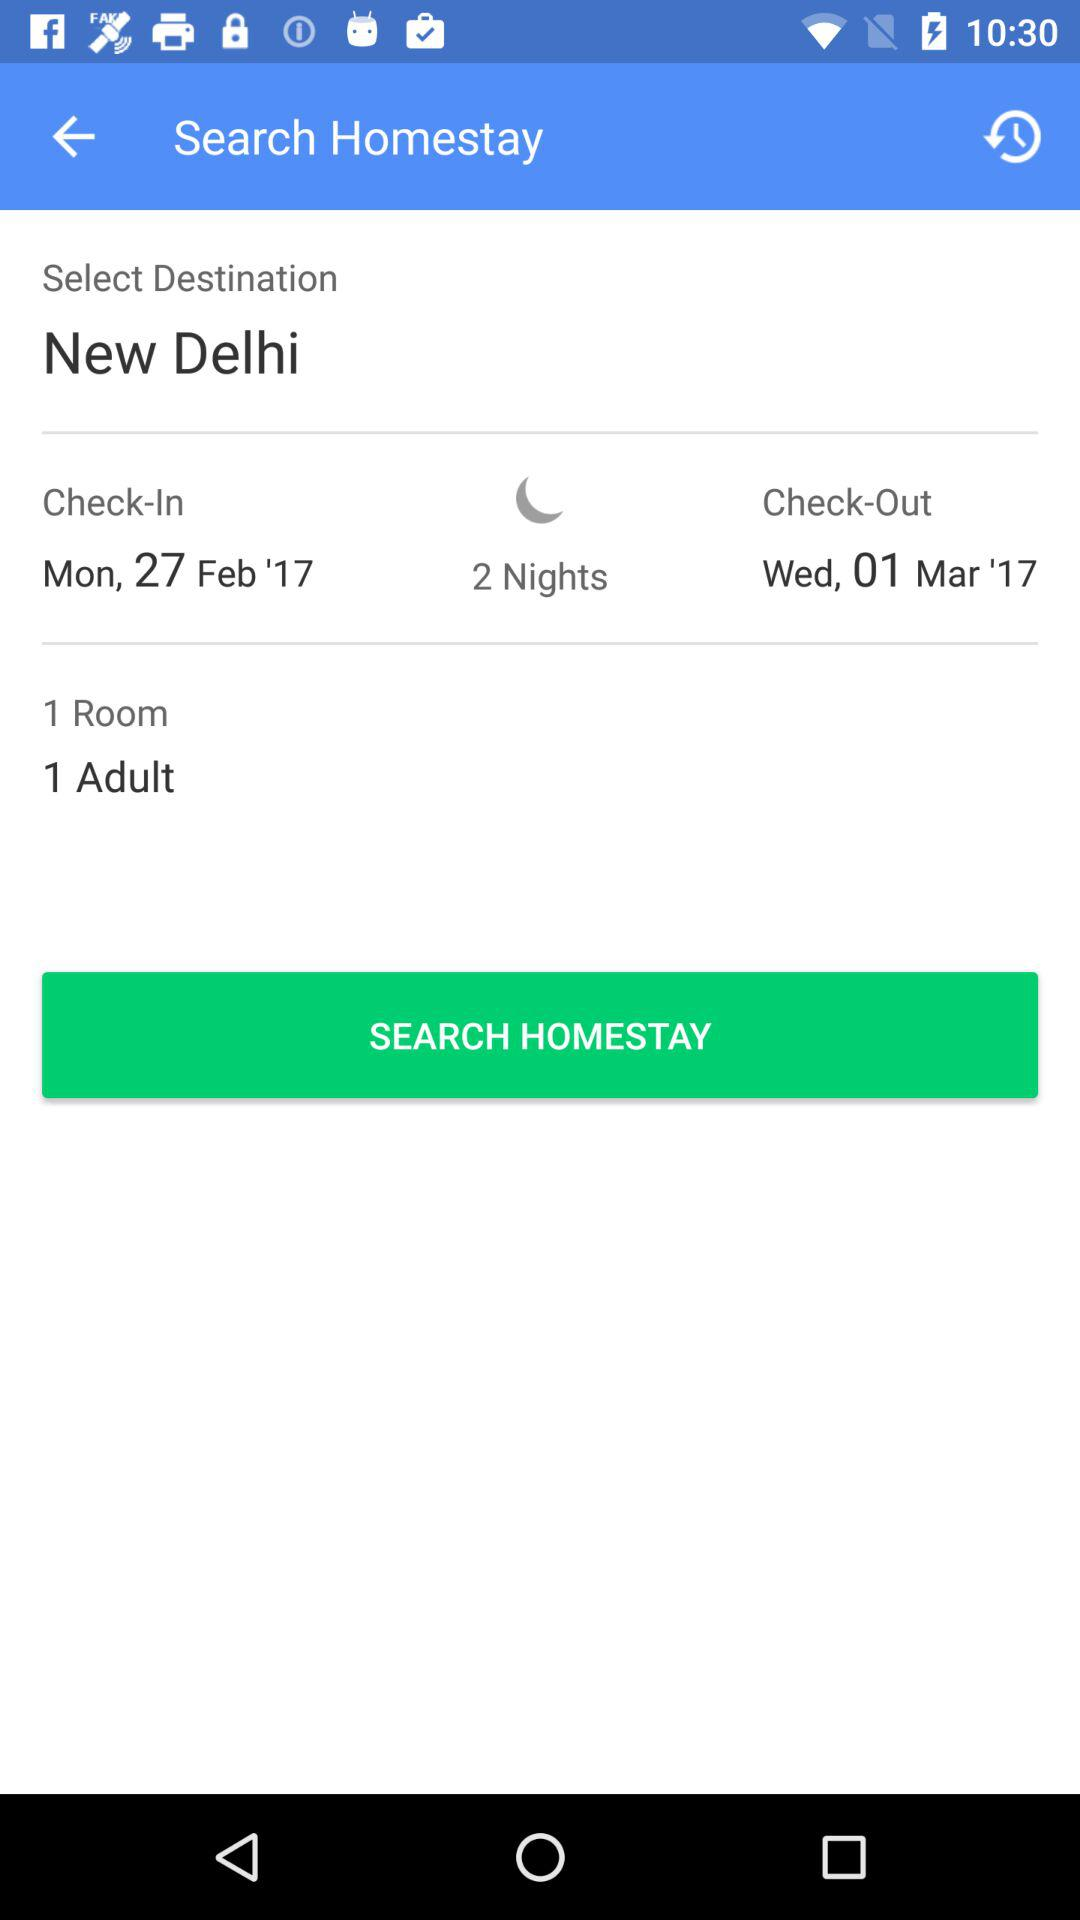For how many nights is the homestay being searched? The homestay is being searched for 2 nights. 